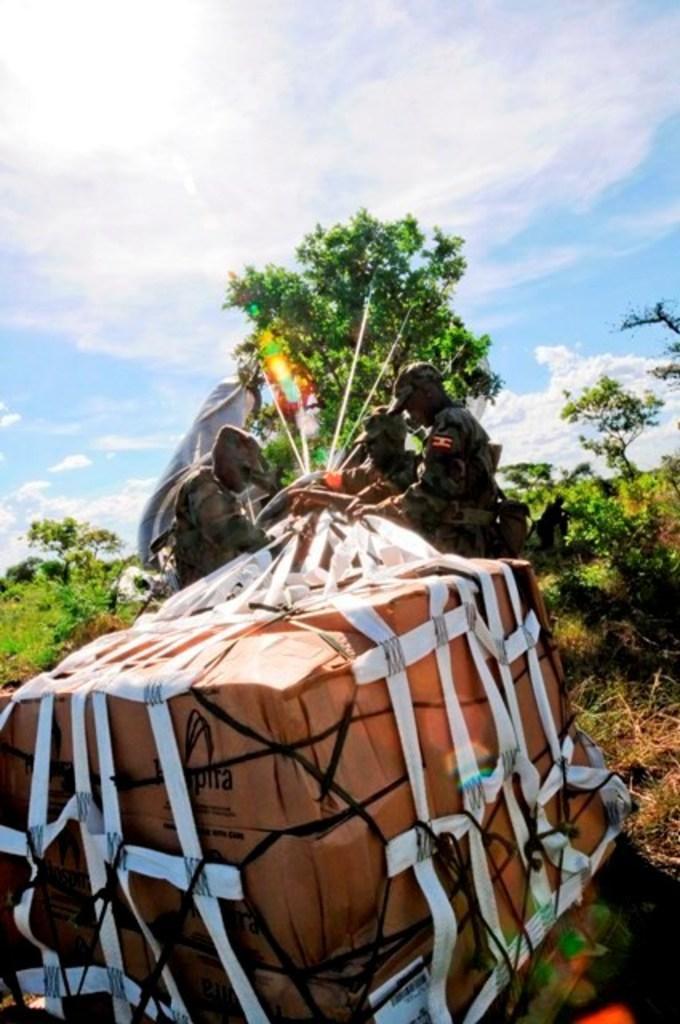Please provide a concise description of this image. In the image I can see some people who are some books which are in the net and also I can see some trees and plants. 